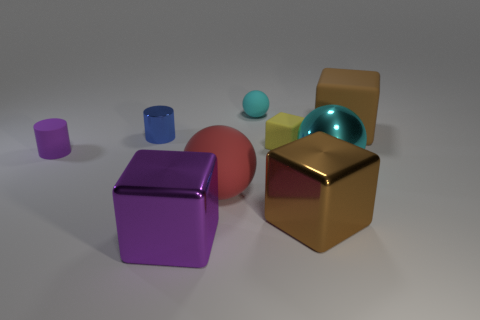Subtract all tiny cubes. How many cubes are left? 3 Subtract all gray blocks. Subtract all yellow spheres. How many blocks are left? 4 Subtract all cubes. How many objects are left? 5 Add 5 small yellow things. How many small yellow things are left? 6 Add 8 small cyan rubber cubes. How many small cyan rubber cubes exist? 8 Subtract 1 yellow cubes. How many objects are left? 8 Subtract all big cyan metallic spheres. Subtract all large purple things. How many objects are left? 7 